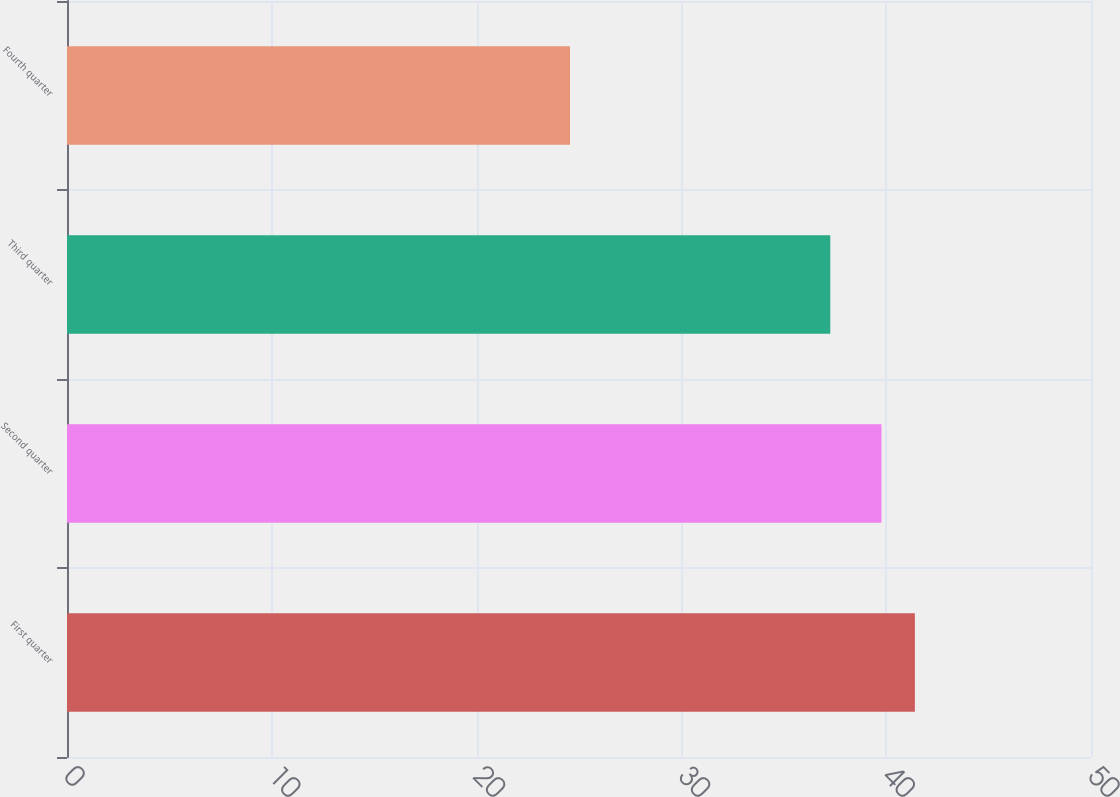<chart> <loc_0><loc_0><loc_500><loc_500><bar_chart><fcel>First quarter<fcel>Second quarter<fcel>Third quarter<fcel>Fourth quarter<nl><fcel>41.4<fcel>39.77<fcel>37.27<fcel>24.56<nl></chart> 